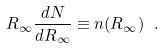<formula> <loc_0><loc_0><loc_500><loc_500>R _ { \infty } \frac { d N } { d R _ { \infty } } \equiv n ( R _ { \infty } ) \ .</formula> 